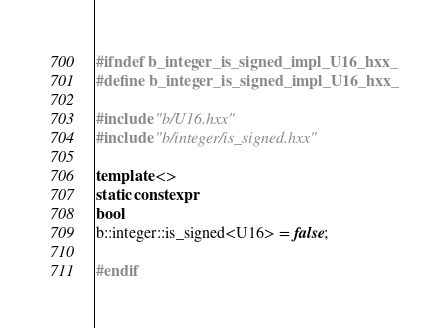<code> <loc_0><loc_0><loc_500><loc_500><_C++_>#ifndef b_integer_is_signed_impl_U16_hxx_
#define b_integer_is_signed_impl_U16_hxx_

#include "b/U16.hxx"
#include "b/integer/is_signed.hxx"

template <>
static constexpr
bool
b::integer::is_signed<U16> = false;

#endif
</code> 